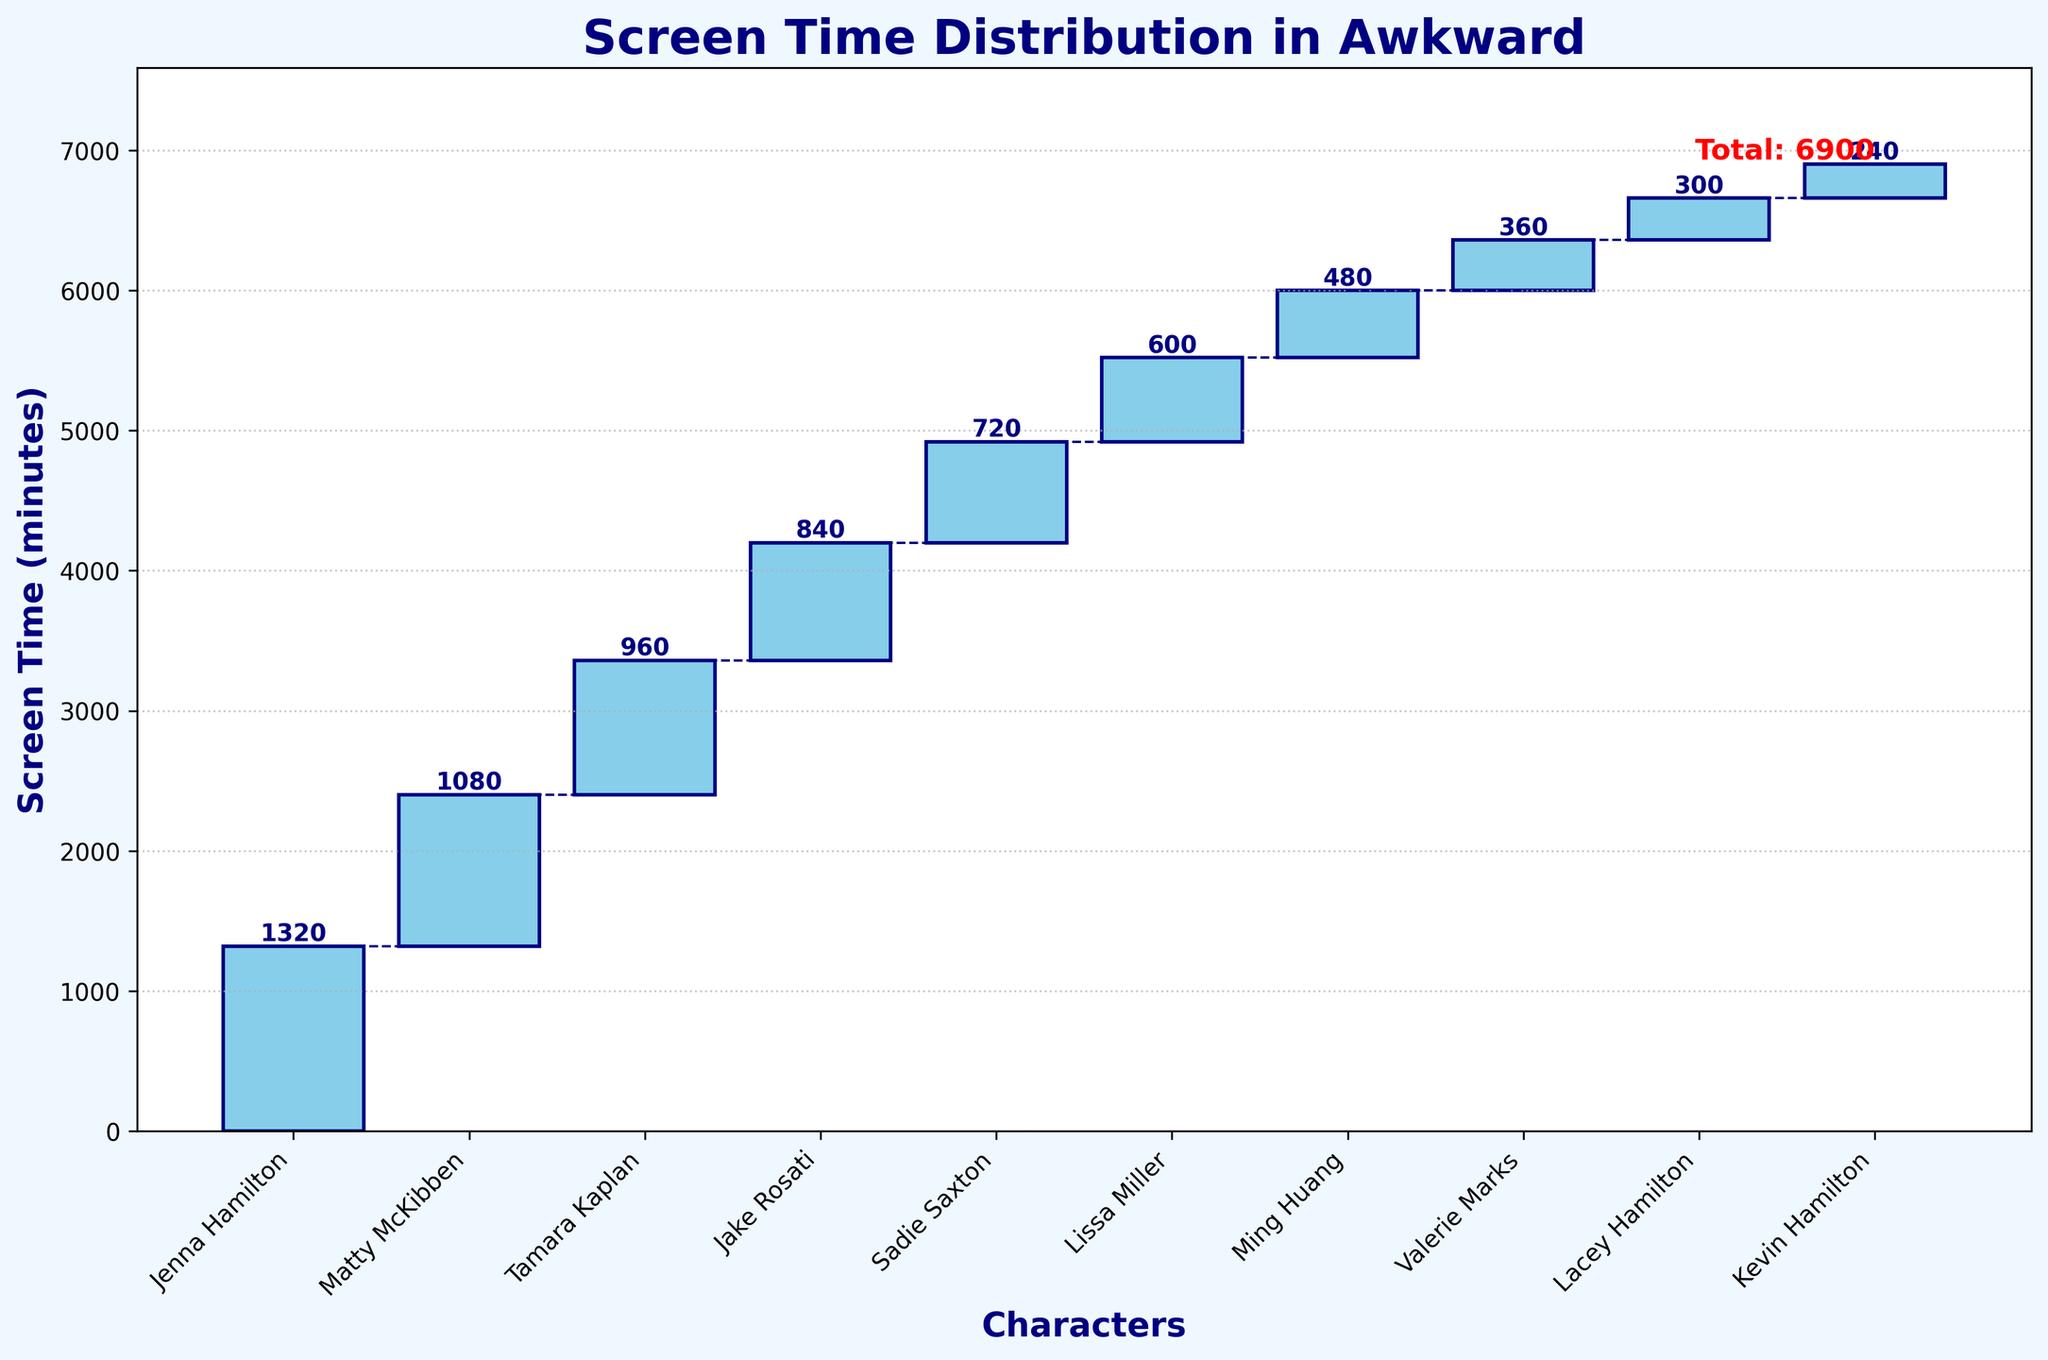What is the title of the figure? The title is the largest text on the figure usually located at the top. Here it's written as 'Screen Time Distribution in Awkward'.
Answer: Screen Time Distribution in Awkward How many main characters are depicted in the Waterfall Chart? Count the number of bars in the chart, excluding any additional total labels. There are bars for Jenna, Matty, Tamara, Jake, Sadie, Lissa, Ming, Valerie, Lacey, and Kevin.
Answer: 10 Which character has the smallest screen time? Look for the bar with the smallest height. Kevin Hamilton shows the shortest bar.
Answer: Kevin Hamilton What is the total screen time for all characters combined? The total screen time is provided as a label near the final cumulative bar. It shows 'Total: 6900'.
Answer: 6900 Who has more screen time, Tamara Kaplan or Jake Rosati? Compare the heights of Tamara's and Jake's bars. Tamara Kaplan has a higher bar than Jake Rosati.
Answer: Tamara Kaplan What is the difference in screen time between Matty McKibben and Sadie Saxton? Find the bars for Matty and Sadie, then subtract the screen time of Sadie from Matty's. Matty has 1080 minutes and Sadie has 720 minutes. The difference is 1080 - 720.
Answer: 360 How much more screen time does Jenna Hamilton have compared to Lissa Miller? Locate and compare the bars for Jenna and Lissa. Subtract Lissa’s screen time (600 minutes) from Jenna's (1320 minutes). The difference is 1320 - 600.
Answer: 720 What is the cumulative screen time after adding Ming Huang's contribution? Accumulate screen time from the first character up to Ming Huang. Sum up screen times of Jenna, Matty, Tamara, Jake, Sadie, Lissa, and then Ming: 1320 + 1080 + 960 + 840 + 720 + 600 + 480.
Answer: 6000 Which two characters have a combined screen time of 2040 minutes? Find which two characters' screen times sum up to 2040. Tamara Kaplan (960) and Jake Rosati (840) together make 1800. Note, adding Lissa's 240 makes a combined 2040.
Answer: Tamara Kaplan and Jake Rosati What is the average screen time for Valerie Marks, Lacey Hamilton, and Kevin Hamilton? Compute the average by adding their screen times and dividing by 3. Valerie has 360, Lacey has 300, and Kevin has 240. Sum: 360 + 300 + 240 = 900. Then, 900 / 3.
Answer: 300 